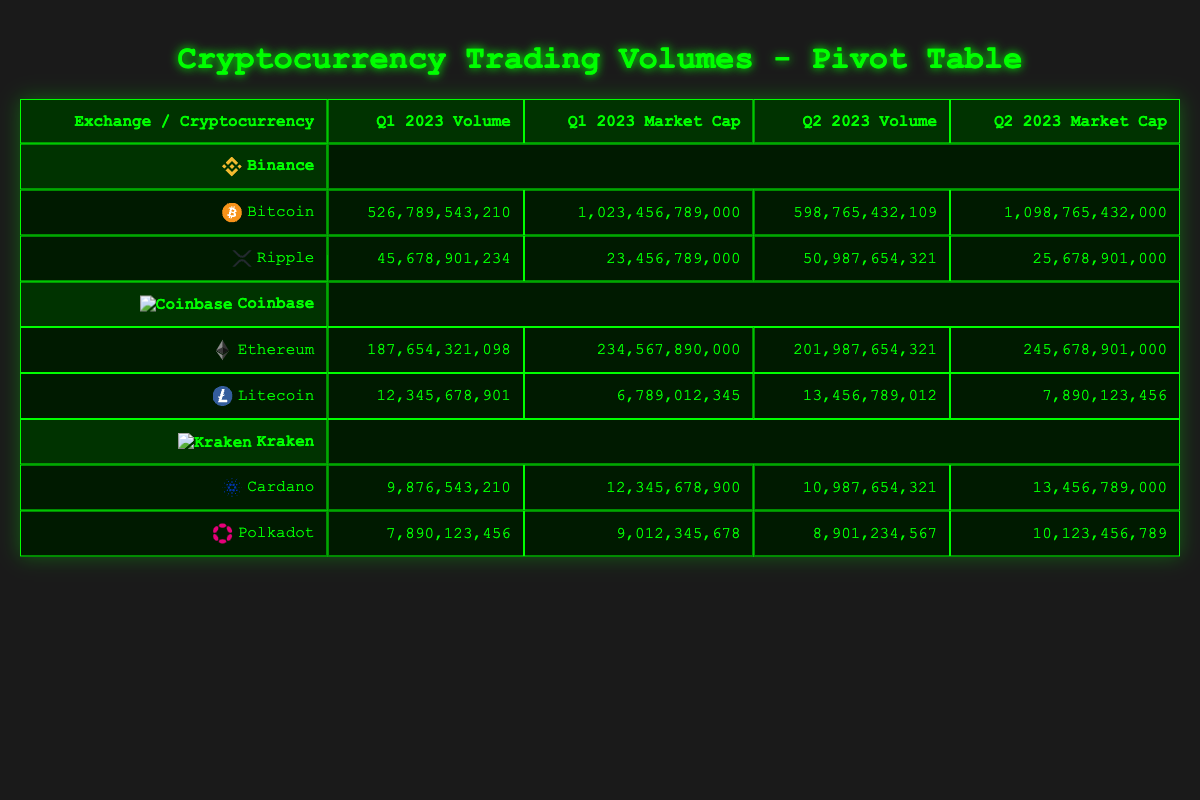What is the trading volume for Bitcoin on Binance in Q1 2023? The table shows that for Bitcoin on Binance during Q1 2023, the trading volume is explicitly listed as 526,789,543,210.
Answer: 526,789,543,210 What was the market cap for Ethereum on Coinbase in Q2 2023? By looking at the table, we see that the market cap for Ethereum on Coinbase in Q2 2023 is 245,678,901,000.
Answer: 245,678,901,000 Which exchange had the highest trading volume for Cardano in Q2 2023? The table shows that Kraken had the trading volume for Cardano in Q2 2023 as 10,987,654,321, while no other exchange had a trading volume for Cardano in the specified quarter. Thus, Kraken had the highest volume for Cardano in Q2 2023.
Answer: Kraken What is the total trading volume for Ripple across Binance in both Q1 and Q2 2023? For Ripple on Binance, the volumes for Q1 and Q2 2023 are 45,678,901,234 and 50,987,654,321 respectively. Therefore, to find the total trading volume, we sum these two values: 45,678,901,234 + 50,987,654,321 = 96,666,555,555.
Answer: 96,666,555,555 Did Kraken have a higher trading volume for Polkadot in Q1 or Q2 2023? The table lists the trading volume for Polkadot on Kraken as 7,890,123,456 in Q1 and 8,901,234,567 in Q2. Comparing these values, Q2 had a higher trading volume (8,901,234,567) than Q1 (7,890,123,456).
Answer: Yes What is the average market cap for Litecoin across both quarters on Coinbase? The table shows the market cap for Litecoin on Coinbase in Q1 as 6,789,012,345 and in Q2 as 7,890,123,456. To find the average, we add these two values (6,789,012,345 + 7,890,123,456 = 14,679,135,801) and divide by 2, giving us an average of 14,679,135,801/2 = 7,339,567,900.5.
Answer: 7,339,567,900.5 Which cryptocurrency had the lowest trading volume on Kraken in Q2 2023? The table shows Cardano with a trading volume of 10,987,654,321 and Polkadot with 8,901,234,567 for Q2 2023 on Kraken. Thus, Polkadot had the lowest volume among the two cryptocurrencies in Q2 on this exchange.
Answer: Polkadot Did Binance have trading volumes for more than two cryptocurrencies in Q1 2023? By examining the table, Binance has listed trading volumes for Bitcoin and Ripple in Q1 2023, specifically two cryptocurrencies, which means it did not exceed two.
Answer: No 